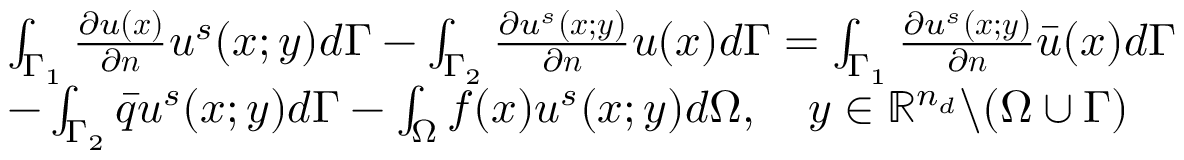<formula> <loc_0><loc_0><loc_500><loc_500>\begin{array} { r l } & { \int _ { \Gamma _ { 1 } } \frac { \partial u ( x ) } { \partial n } u ^ { s } ( x ; y ) d \Gamma - \int _ { \Gamma _ { 2 } } \frac { \partial u ^ { s } ( x ; y ) } { \partial n } u ( x ) d \Gamma = \int _ { \Gamma _ { 1 } } \frac { \partial u ^ { s } ( x ; y ) } { \partial n } \bar { u } ( x ) d \Gamma } \\ & { - \int _ { \Gamma _ { 2 } } \bar { q } u ^ { s } ( x ; y ) d \Gamma - \int _ { \Omega } f ( x ) u ^ { s } ( x ; y ) d \Omega , \quad y \in \mathbb { R } ^ { n _ { d } } \ ( \Omega \cup \Gamma ) } \end{array}</formula> 